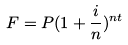<formula> <loc_0><loc_0><loc_500><loc_500>F = P ( 1 + \frac { i } { n } ) ^ { n t }</formula> 